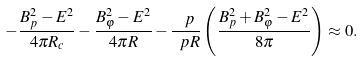<formula> <loc_0><loc_0><loc_500><loc_500>- \frac { B _ { p } ^ { 2 } - E ^ { 2 } } { 4 \pi R _ { c } } - \frac { B _ { \varphi } ^ { 2 } - E ^ { 2 } } { 4 \pi R } - \frac { \ p } { \ p R } \left ( \frac { B _ { p } ^ { 2 } + B _ { \varphi } ^ { 2 } - E ^ { 2 } } { 8 \pi } \right ) \approx 0 .</formula> 